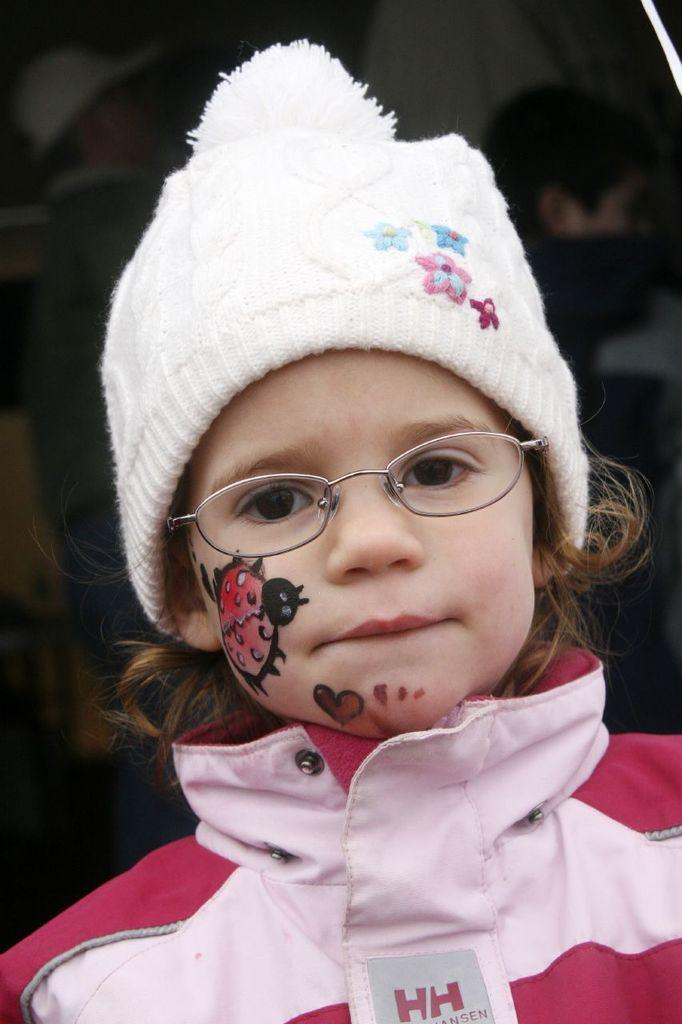What is the main subject of the image? The main subject of the image is a girl. Can you describe what the girl is wearing on her face? The girl is wearing glasses. What type of headwear is the girl wearing? The girl is wearing a cap. What type of calculator is the girl using in the image? There is no calculator present in the image. What is the girl's income based on the image? There is no information about the girl's income in the image. 